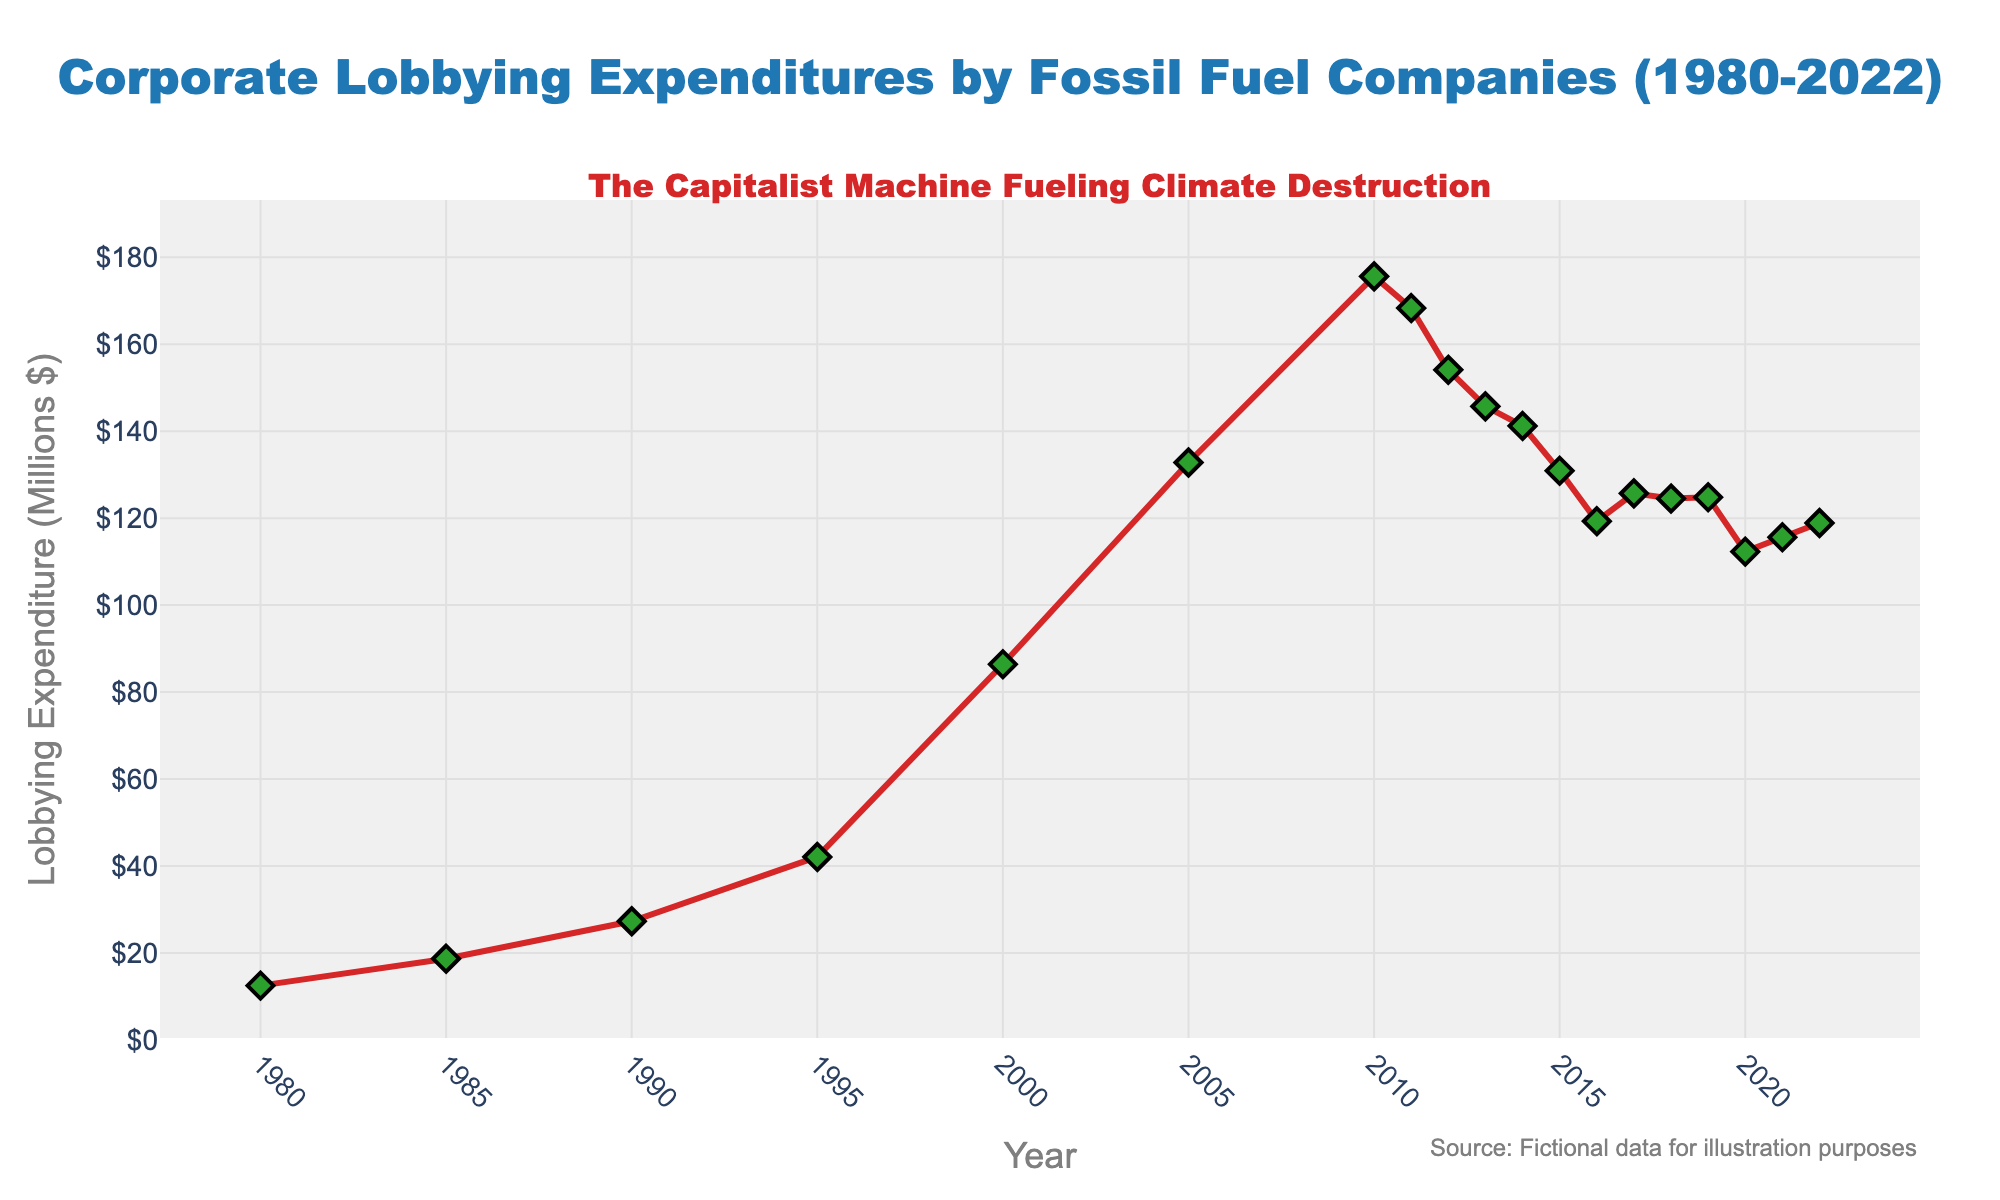What is the overall trend in lobbying expenditures by fossil fuel companies from 1980 to 2022? Over the period from 1980 to 2022, the lobbying expenditures by fossil fuel companies in the US show an overall increasing trend. Starting from $12.5 Million in 1980, it peaks at $175.6 Million in 2010 before experiencing a slight decline and stabilizing around the $110-$130 Million range in recent years.
Answer: Increasing What year had the highest lobbying expenditure and what was the amount? The highest lobbying expenditure occurred in 2010, with $175.6 Million spent.
Answer: 2010, $175.6 Million By how much did lobbying expenditures increase from 1980 to 2000? In 1980, the expenditure was $12.5 Million, and by 2000, it had risen to $86.4 Million. The increase is calculated as $86.4 Million - $12.5 Million = $73.9 Million.
Answer: $73.9 Million Which year experienced the largest single-year decline in lobbying expenditures, and what was the change in expenditure? The largest single-year decline occurred from 2010 to 2011, with a change in expenditure of $175.6 Million - $168.3 Million = $7.3 Million.
Answer: 2010 to 2011, $7.3 Million What was the average lobbying expenditure from 2010 to 2022? Adding the values from 2010 to 2022 and then dividing by the number of years (13): (175.6 + 168.3 + 154.1 + 145.7 + 141.2 + 130.9 + 119.3 + 125.7 + 124.5 + 124.8 + 112.3 + 115.6 + 118.9) / 13 ≈ 136.94.
Answer: $136.94 Million How did lobbying expenditures change from 2005 to 2015? In 2005, lobbying expenditure was $132.8 Million, and in 2015, it was $130.9 Million. The change in expenditure is $130.9 Million - $132.8 Million = -$1.9 Million, indicating a slight decrease.
Answer: Decreased by $1.9 Million Compare the lobbying expenditures in 1985 and 2018. Which year had higher expenditure and by how much? In 1985, the expenditure was $18.7 Million, and in 2018, it was $124.5 Million. 2018 had higher expenditure by $124.5 Million - $18.7 Million = $105.8 Million.
Answer: 2018, by $105.8 Million What trend is observed after 2010 in lobbying expenditures by fossil fuel companies? After 2010, there is a decreasing trend observed in lobbying expenditures, with values falling from $175.6 Million in 2010 to around $112.3 Million in 2020, followed by slight fluctuation.
Answer: Decreasing What is the difference in lobbying expenditure between the years 2000 and 2020? In 2000, the expenditure was $86.4 Million, and in 2020, it was $112.3 Million. The difference is $112.3 Million - $86.4 Million = $25.9 Million.
Answer: $25.9 Million Which three consecutive years had the lowest combined lobbying expenditures from 1980 to 2022? To find this, we look at three-year moving sums and compare. The lowest combined expenditures occur from 1980 to 1982: ($12.5 Million + $18.7 Million + $27.3 Million) = $58.5 Million.
Answer: 1980 to 1982, $58.5 Million 